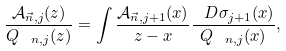Convert formula to latex. <formula><loc_0><loc_0><loc_500><loc_500>\frac { \mathcal { A } _ { \vec { n } , j } ( z ) } { Q _ { \ n , j } ( z ) } = \int \frac { \mathcal { A } _ { \vec { n } , j + 1 } ( x ) } { z - x } \frac { \ D \sigma _ { j + 1 } ( x ) } { Q _ { \ n , j } ( x ) } ,</formula> 